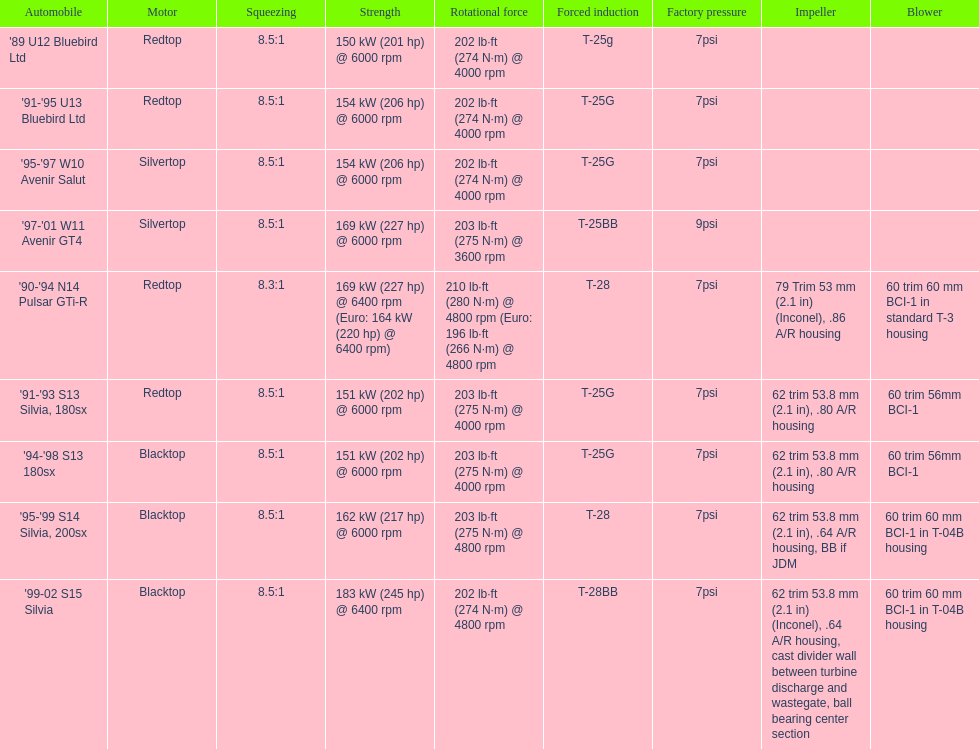Which engines share similarities with the first entry ('89 u12 bluebird ltd)? '91-'95 U13 Bluebird Ltd, '90-'94 N14 Pulsar GTi-R, '91-'93 S13 Silvia, 180sx. 